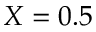<formula> <loc_0><loc_0><loc_500><loc_500>X = 0 . 5</formula> 